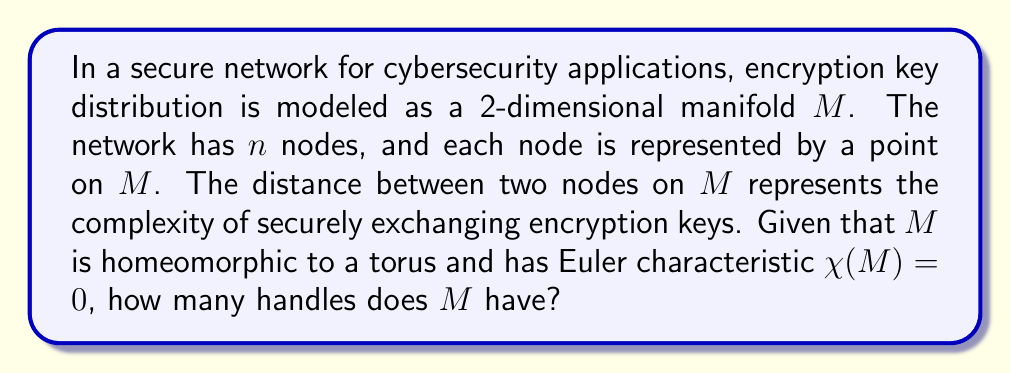Solve this math problem. To solve this problem, we need to understand the relationship between the topology of a manifold, its Euler characteristic, and the number of handles it has. This analysis is relevant to cybersecurity as it helps in understanding the complexity of key distribution in a secure network.

1) First, recall the formula for the Euler characteristic of a surface:

   $$\chi = 2 - 2g$$

   where $g$ is the genus (number of handles) of the surface.

2) We are given that $\chi(M) = 0$. Let's substitute this into the formula:

   $$0 = 2 - 2g$$

3) Solving for $g$:

   $$2g = 2$$
   $$g = 1$$

4) The fact that $M$ is homeomorphic to a torus confirms our result, as a torus is the standard example of a surface with one handle.

In the context of encryption key distribution, this topology suggests that the network has a circular structure with one additional pathway for key exchange, potentially providing redundancy or alternative routes for secure communication.
Answer: $M$ has 1 handle. 